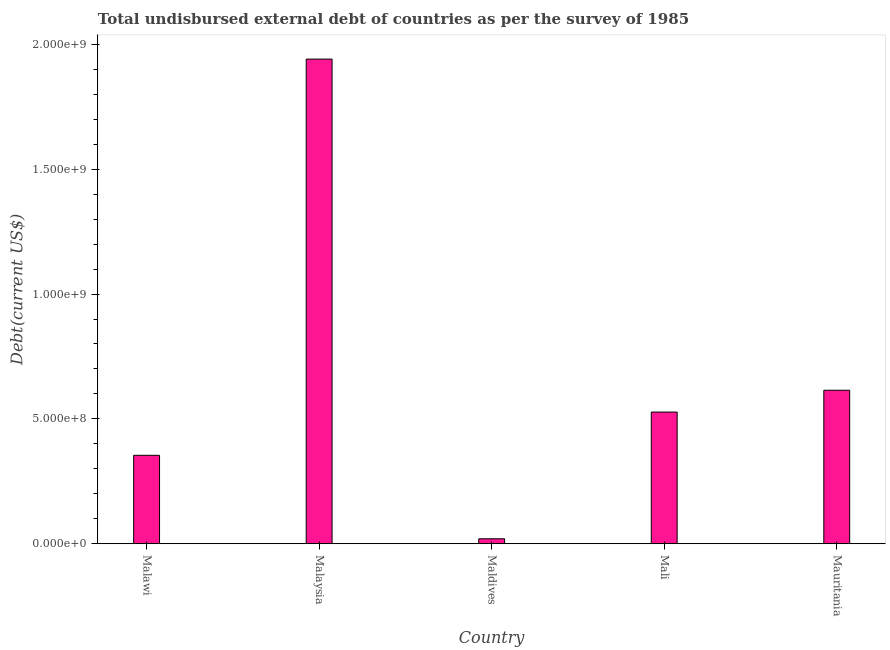Does the graph contain any zero values?
Keep it short and to the point. No. Does the graph contain grids?
Your response must be concise. No. What is the title of the graph?
Provide a short and direct response. Total undisbursed external debt of countries as per the survey of 1985. What is the label or title of the Y-axis?
Give a very brief answer. Debt(current US$). What is the total debt in Malaysia?
Ensure brevity in your answer.  1.94e+09. Across all countries, what is the maximum total debt?
Ensure brevity in your answer.  1.94e+09. Across all countries, what is the minimum total debt?
Ensure brevity in your answer.  1.99e+07. In which country was the total debt maximum?
Your response must be concise. Malaysia. In which country was the total debt minimum?
Offer a terse response. Maldives. What is the sum of the total debt?
Offer a very short reply. 3.46e+09. What is the difference between the total debt in Malawi and Maldives?
Ensure brevity in your answer.  3.34e+08. What is the average total debt per country?
Give a very brief answer. 6.91e+08. What is the median total debt?
Ensure brevity in your answer.  5.27e+08. What is the ratio of the total debt in Mali to that in Mauritania?
Your answer should be compact. 0.86. Is the total debt in Malaysia less than that in Mauritania?
Your answer should be compact. No. Is the difference between the total debt in Maldives and Mauritania greater than the difference between any two countries?
Offer a very short reply. No. What is the difference between the highest and the second highest total debt?
Keep it short and to the point. 1.33e+09. Is the sum of the total debt in Maldives and Mali greater than the maximum total debt across all countries?
Keep it short and to the point. No. What is the difference between the highest and the lowest total debt?
Your answer should be very brief. 1.92e+09. Are the values on the major ticks of Y-axis written in scientific E-notation?
Give a very brief answer. Yes. What is the Debt(current US$) of Malawi?
Give a very brief answer. 3.54e+08. What is the Debt(current US$) in Malaysia?
Provide a succinct answer. 1.94e+09. What is the Debt(current US$) in Maldives?
Provide a succinct answer. 1.99e+07. What is the Debt(current US$) of Mali?
Your answer should be very brief. 5.27e+08. What is the Debt(current US$) of Mauritania?
Make the answer very short. 6.15e+08. What is the difference between the Debt(current US$) in Malawi and Malaysia?
Your answer should be very brief. -1.59e+09. What is the difference between the Debt(current US$) in Malawi and Maldives?
Give a very brief answer. 3.34e+08. What is the difference between the Debt(current US$) in Malawi and Mali?
Make the answer very short. -1.73e+08. What is the difference between the Debt(current US$) in Malawi and Mauritania?
Your answer should be compact. -2.61e+08. What is the difference between the Debt(current US$) in Malaysia and Maldives?
Keep it short and to the point. 1.92e+09. What is the difference between the Debt(current US$) in Malaysia and Mali?
Provide a short and direct response. 1.41e+09. What is the difference between the Debt(current US$) in Malaysia and Mauritania?
Ensure brevity in your answer.  1.33e+09. What is the difference between the Debt(current US$) in Maldives and Mali?
Offer a very short reply. -5.08e+08. What is the difference between the Debt(current US$) in Maldives and Mauritania?
Offer a terse response. -5.95e+08. What is the difference between the Debt(current US$) in Mali and Mauritania?
Offer a terse response. -8.73e+07. What is the ratio of the Debt(current US$) in Malawi to that in Malaysia?
Provide a succinct answer. 0.18. What is the ratio of the Debt(current US$) in Malawi to that in Maldives?
Your response must be concise. 17.79. What is the ratio of the Debt(current US$) in Malawi to that in Mali?
Your answer should be very brief. 0.67. What is the ratio of the Debt(current US$) in Malawi to that in Mauritania?
Offer a very short reply. 0.58. What is the ratio of the Debt(current US$) in Malaysia to that in Maldives?
Keep it short and to the point. 97.5. What is the ratio of the Debt(current US$) in Malaysia to that in Mali?
Your answer should be very brief. 3.68. What is the ratio of the Debt(current US$) in Malaysia to that in Mauritania?
Make the answer very short. 3.16. What is the ratio of the Debt(current US$) in Maldives to that in Mali?
Offer a terse response. 0.04. What is the ratio of the Debt(current US$) in Maldives to that in Mauritania?
Provide a short and direct response. 0.03. What is the ratio of the Debt(current US$) in Mali to that in Mauritania?
Ensure brevity in your answer.  0.86. 